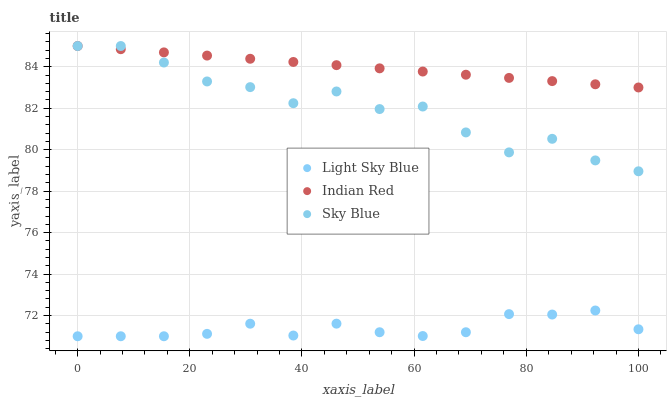Does Light Sky Blue have the minimum area under the curve?
Answer yes or no. Yes. Does Indian Red have the maximum area under the curve?
Answer yes or no. Yes. Does Indian Red have the minimum area under the curve?
Answer yes or no. No. Does Light Sky Blue have the maximum area under the curve?
Answer yes or no. No. Is Indian Red the smoothest?
Answer yes or no. Yes. Is Sky Blue the roughest?
Answer yes or no. Yes. Is Light Sky Blue the smoothest?
Answer yes or no. No. Is Light Sky Blue the roughest?
Answer yes or no. No. Does Light Sky Blue have the lowest value?
Answer yes or no. Yes. Does Indian Red have the lowest value?
Answer yes or no. No. Does Indian Red have the highest value?
Answer yes or no. Yes. Does Light Sky Blue have the highest value?
Answer yes or no. No. Is Light Sky Blue less than Sky Blue?
Answer yes or no. Yes. Is Indian Red greater than Light Sky Blue?
Answer yes or no. Yes. Does Indian Red intersect Sky Blue?
Answer yes or no. Yes. Is Indian Red less than Sky Blue?
Answer yes or no. No. Is Indian Red greater than Sky Blue?
Answer yes or no. No. Does Light Sky Blue intersect Sky Blue?
Answer yes or no. No. 